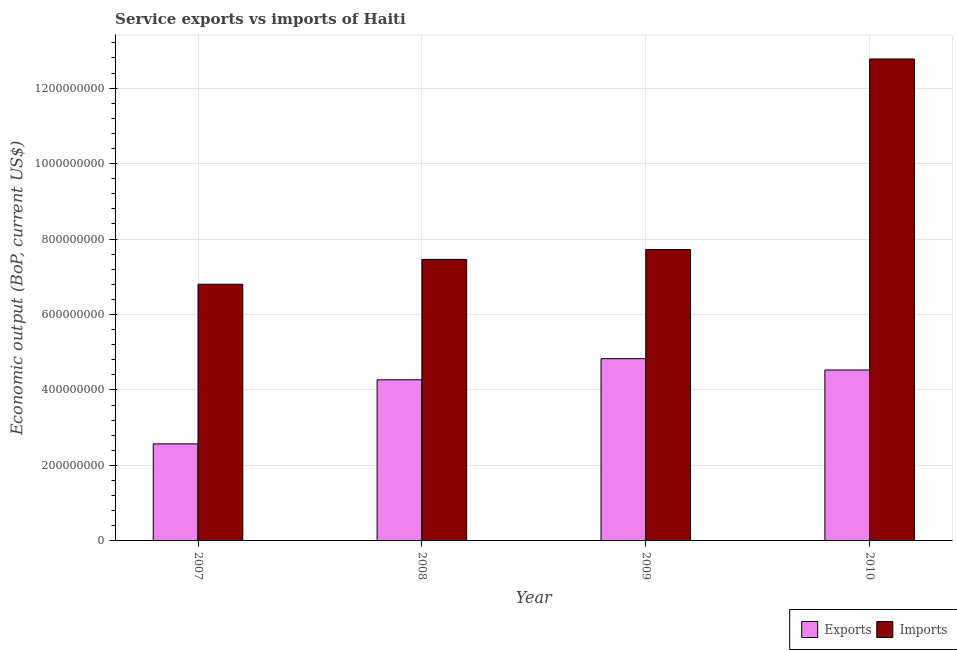How many different coloured bars are there?
Offer a terse response. 2. How many groups of bars are there?
Your response must be concise. 4. Are the number of bars on each tick of the X-axis equal?
Ensure brevity in your answer.  Yes. How many bars are there on the 3rd tick from the left?
Provide a succinct answer. 2. How many bars are there on the 3rd tick from the right?
Give a very brief answer. 2. In how many cases, is the number of bars for a given year not equal to the number of legend labels?
Ensure brevity in your answer.  0. What is the amount of service imports in 2010?
Your response must be concise. 1.28e+09. Across all years, what is the maximum amount of service imports?
Provide a short and direct response. 1.28e+09. Across all years, what is the minimum amount of service exports?
Your response must be concise. 2.57e+08. In which year was the amount of service exports minimum?
Provide a succinct answer. 2007. What is the total amount of service imports in the graph?
Your answer should be very brief. 3.48e+09. What is the difference between the amount of service exports in 2007 and that in 2009?
Provide a succinct answer. -2.26e+08. What is the difference between the amount of service imports in 2008 and the amount of service exports in 2007?
Keep it short and to the point. 6.58e+07. What is the average amount of service imports per year?
Provide a succinct answer. 8.69e+08. In the year 2007, what is the difference between the amount of service imports and amount of service exports?
Offer a terse response. 0. What is the ratio of the amount of service imports in 2007 to that in 2009?
Offer a terse response. 0.88. Is the amount of service imports in 2007 less than that in 2010?
Your answer should be very brief. Yes. What is the difference between the highest and the second highest amount of service exports?
Give a very brief answer. 3.00e+07. What is the difference between the highest and the lowest amount of service imports?
Make the answer very short. 5.97e+08. In how many years, is the amount of service imports greater than the average amount of service imports taken over all years?
Provide a succinct answer. 1. What does the 2nd bar from the left in 2009 represents?
Offer a very short reply. Imports. What does the 1st bar from the right in 2008 represents?
Offer a very short reply. Imports. How many years are there in the graph?
Your answer should be compact. 4. What is the difference between two consecutive major ticks on the Y-axis?
Offer a very short reply. 2.00e+08. Where does the legend appear in the graph?
Your answer should be compact. Bottom right. What is the title of the graph?
Your answer should be compact. Service exports vs imports of Haiti. What is the label or title of the X-axis?
Your answer should be compact. Year. What is the label or title of the Y-axis?
Offer a terse response. Economic output (BoP, current US$). What is the Economic output (BoP, current US$) of Exports in 2007?
Make the answer very short. 2.57e+08. What is the Economic output (BoP, current US$) of Imports in 2007?
Your response must be concise. 6.80e+08. What is the Economic output (BoP, current US$) of Exports in 2008?
Offer a terse response. 4.27e+08. What is the Economic output (BoP, current US$) in Imports in 2008?
Give a very brief answer. 7.46e+08. What is the Economic output (BoP, current US$) of Exports in 2009?
Keep it short and to the point. 4.83e+08. What is the Economic output (BoP, current US$) in Imports in 2009?
Ensure brevity in your answer.  7.72e+08. What is the Economic output (BoP, current US$) in Exports in 2010?
Provide a short and direct response. 4.53e+08. What is the Economic output (BoP, current US$) of Imports in 2010?
Provide a short and direct response. 1.28e+09. Across all years, what is the maximum Economic output (BoP, current US$) in Exports?
Ensure brevity in your answer.  4.83e+08. Across all years, what is the maximum Economic output (BoP, current US$) in Imports?
Provide a short and direct response. 1.28e+09. Across all years, what is the minimum Economic output (BoP, current US$) of Exports?
Your answer should be compact. 2.57e+08. Across all years, what is the minimum Economic output (BoP, current US$) of Imports?
Your answer should be very brief. 6.80e+08. What is the total Economic output (BoP, current US$) in Exports in the graph?
Your answer should be compact. 1.62e+09. What is the total Economic output (BoP, current US$) in Imports in the graph?
Offer a terse response. 3.48e+09. What is the difference between the Economic output (BoP, current US$) in Exports in 2007 and that in 2008?
Your answer should be compact. -1.70e+08. What is the difference between the Economic output (BoP, current US$) of Imports in 2007 and that in 2008?
Give a very brief answer. -6.58e+07. What is the difference between the Economic output (BoP, current US$) of Exports in 2007 and that in 2009?
Offer a very short reply. -2.26e+08. What is the difference between the Economic output (BoP, current US$) of Imports in 2007 and that in 2009?
Offer a very short reply. -9.18e+07. What is the difference between the Economic output (BoP, current US$) in Exports in 2007 and that in 2010?
Keep it short and to the point. -1.96e+08. What is the difference between the Economic output (BoP, current US$) in Imports in 2007 and that in 2010?
Ensure brevity in your answer.  -5.97e+08. What is the difference between the Economic output (BoP, current US$) of Exports in 2008 and that in 2009?
Your answer should be very brief. -5.60e+07. What is the difference between the Economic output (BoP, current US$) of Imports in 2008 and that in 2009?
Your response must be concise. -2.61e+07. What is the difference between the Economic output (BoP, current US$) in Exports in 2008 and that in 2010?
Keep it short and to the point. -2.60e+07. What is the difference between the Economic output (BoP, current US$) in Imports in 2008 and that in 2010?
Keep it short and to the point. -5.31e+08. What is the difference between the Economic output (BoP, current US$) in Exports in 2009 and that in 2010?
Offer a very short reply. 3.00e+07. What is the difference between the Economic output (BoP, current US$) in Imports in 2009 and that in 2010?
Offer a very short reply. -5.05e+08. What is the difference between the Economic output (BoP, current US$) of Exports in 2007 and the Economic output (BoP, current US$) of Imports in 2008?
Give a very brief answer. -4.89e+08. What is the difference between the Economic output (BoP, current US$) in Exports in 2007 and the Economic output (BoP, current US$) in Imports in 2009?
Provide a short and direct response. -5.15e+08. What is the difference between the Economic output (BoP, current US$) of Exports in 2007 and the Economic output (BoP, current US$) of Imports in 2010?
Your answer should be compact. -1.02e+09. What is the difference between the Economic output (BoP, current US$) in Exports in 2008 and the Economic output (BoP, current US$) in Imports in 2009?
Your answer should be very brief. -3.45e+08. What is the difference between the Economic output (BoP, current US$) in Exports in 2008 and the Economic output (BoP, current US$) in Imports in 2010?
Offer a terse response. -8.50e+08. What is the difference between the Economic output (BoP, current US$) of Exports in 2009 and the Economic output (BoP, current US$) of Imports in 2010?
Your response must be concise. -7.94e+08. What is the average Economic output (BoP, current US$) of Exports per year?
Keep it short and to the point. 4.05e+08. What is the average Economic output (BoP, current US$) in Imports per year?
Make the answer very short. 8.69e+08. In the year 2007, what is the difference between the Economic output (BoP, current US$) of Exports and Economic output (BoP, current US$) of Imports?
Ensure brevity in your answer.  -4.23e+08. In the year 2008, what is the difference between the Economic output (BoP, current US$) in Exports and Economic output (BoP, current US$) in Imports?
Make the answer very short. -3.19e+08. In the year 2009, what is the difference between the Economic output (BoP, current US$) in Exports and Economic output (BoP, current US$) in Imports?
Your answer should be compact. -2.89e+08. In the year 2010, what is the difference between the Economic output (BoP, current US$) of Exports and Economic output (BoP, current US$) of Imports?
Your answer should be compact. -8.24e+08. What is the ratio of the Economic output (BoP, current US$) of Exports in 2007 to that in 2008?
Provide a succinct answer. 0.6. What is the ratio of the Economic output (BoP, current US$) in Imports in 2007 to that in 2008?
Provide a short and direct response. 0.91. What is the ratio of the Economic output (BoP, current US$) of Exports in 2007 to that in 2009?
Provide a succinct answer. 0.53. What is the ratio of the Economic output (BoP, current US$) of Imports in 2007 to that in 2009?
Ensure brevity in your answer.  0.88. What is the ratio of the Economic output (BoP, current US$) of Exports in 2007 to that in 2010?
Provide a succinct answer. 0.57. What is the ratio of the Economic output (BoP, current US$) of Imports in 2007 to that in 2010?
Give a very brief answer. 0.53. What is the ratio of the Economic output (BoP, current US$) of Exports in 2008 to that in 2009?
Ensure brevity in your answer.  0.88. What is the ratio of the Economic output (BoP, current US$) in Imports in 2008 to that in 2009?
Offer a terse response. 0.97. What is the ratio of the Economic output (BoP, current US$) in Exports in 2008 to that in 2010?
Give a very brief answer. 0.94. What is the ratio of the Economic output (BoP, current US$) in Imports in 2008 to that in 2010?
Offer a very short reply. 0.58. What is the ratio of the Economic output (BoP, current US$) in Exports in 2009 to that in 2010?
Your answer should be very brief. 1.07. What is the ratio of the Economic output (BoP, current US$) of Imports in 2009 to that in 2010?
Provide a succinct answer. 0.6. What is the difference between the highest and the second highest Economic output (BoP, current US$) in Exports?
Offer a very short reply. 3.00e+07. What is the difference between the highest and the second highest Economic output (BoP, current US$) of Imports?
Your response must be concise. 5.05e+08. What is the difference between the highest and the lowest Economic output (BoP, current US$) in Exports?
Offer a terse response. 2.26e+08. What is the difference between the highest and the lowest Economic output (BoP, current US$) of Imports?
Your answer should be very brief. 5.97e+08. 